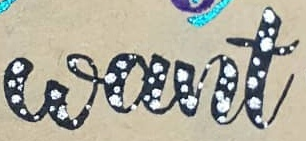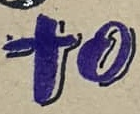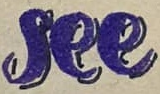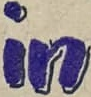Transcribe the words shown in these images in order, separated by a semicolon. want; to; see; in 